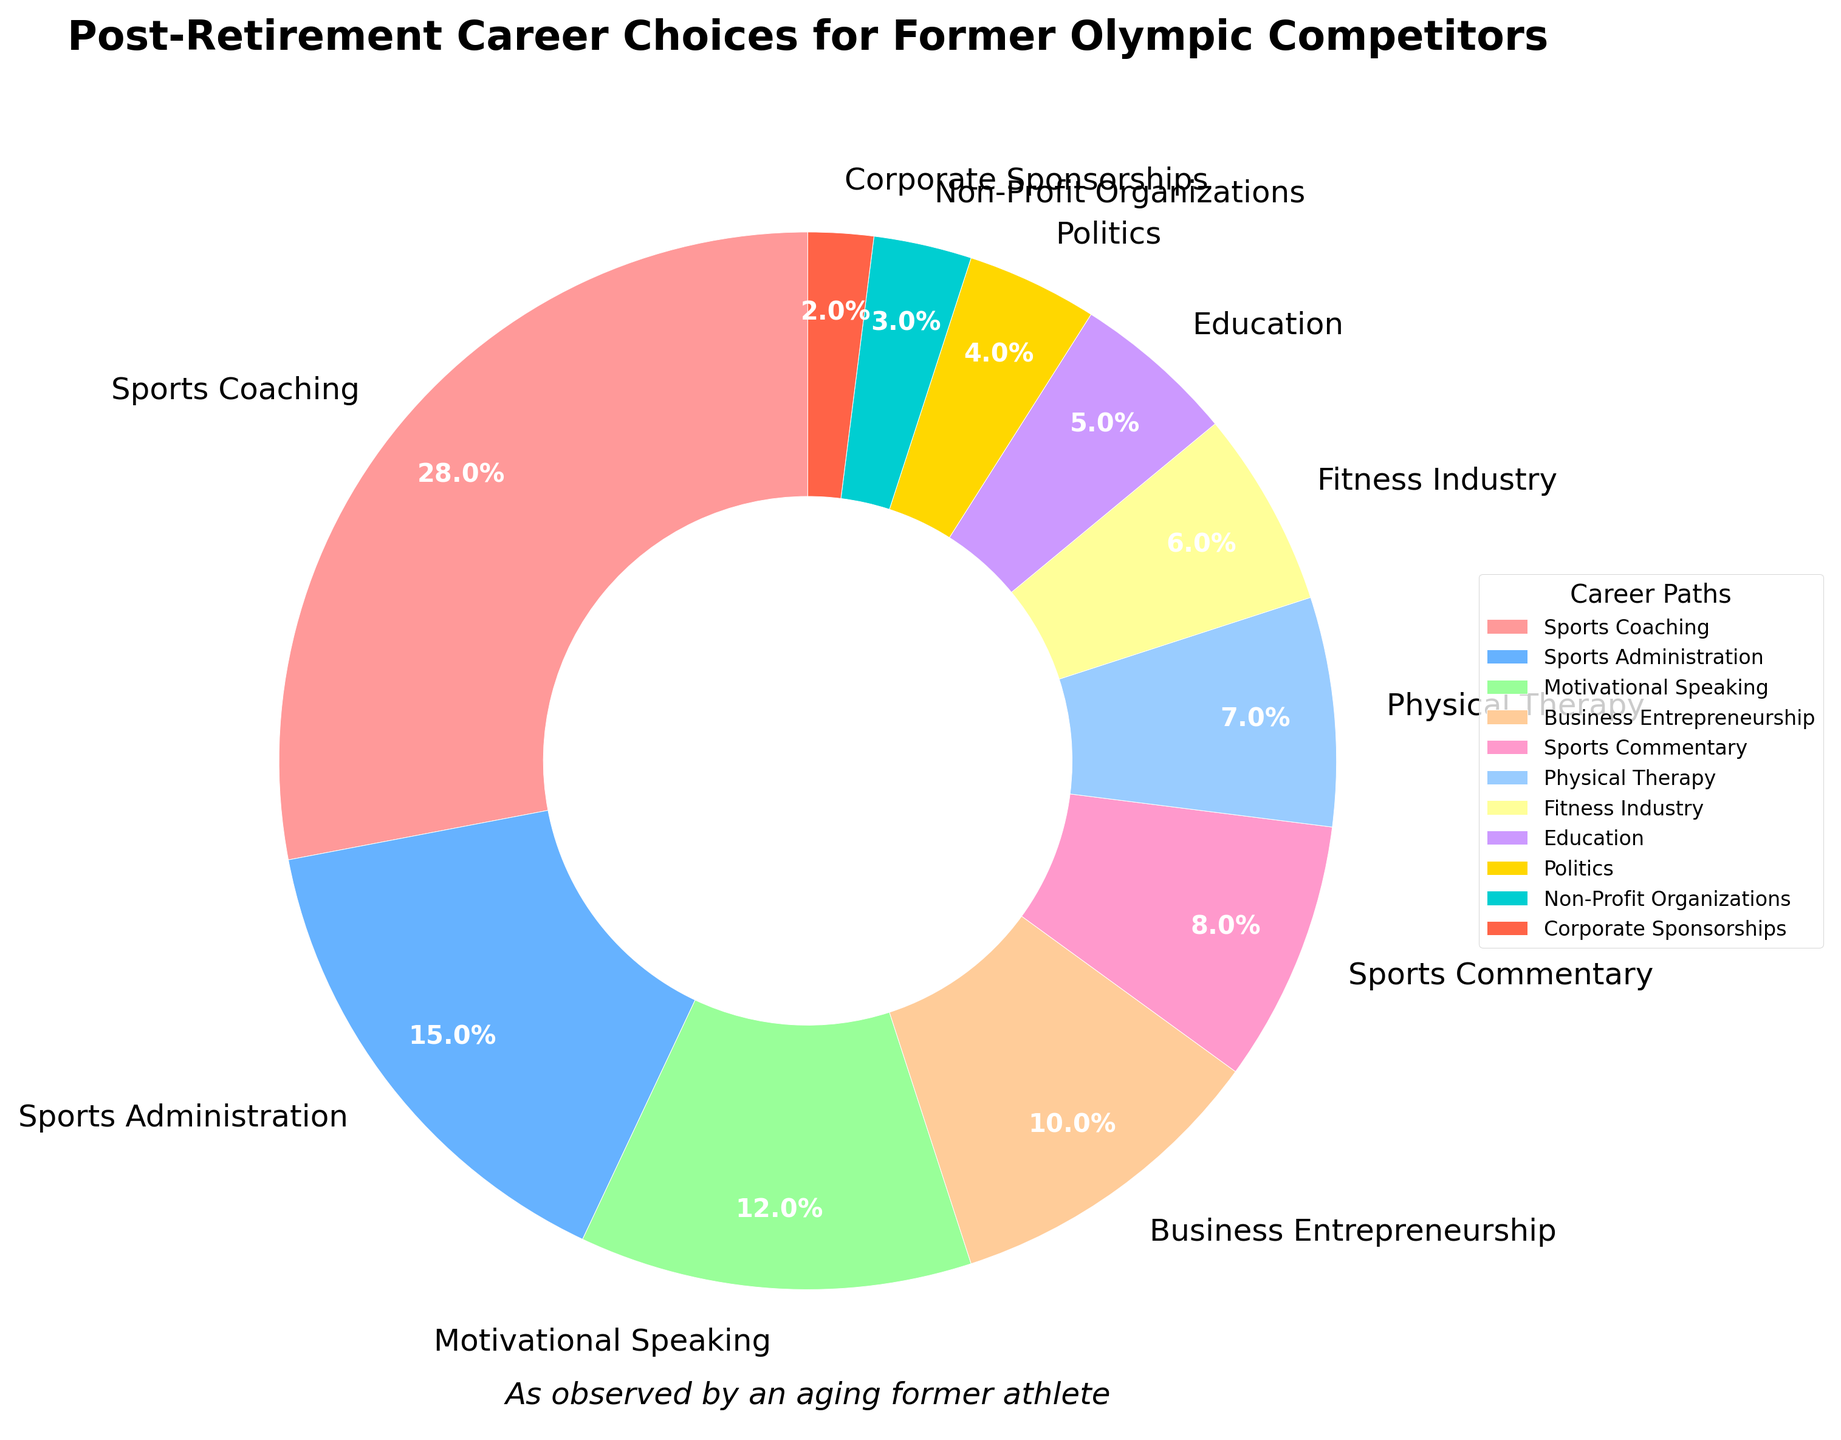Which career path is the most popular among former Olympic competitors? The largest segment in the pie chart represents the most popular career path. In this case, it is Sports Coaching with 28%.
Answer: Sports Coaching What is the combined percentage of former Olympians who went into Business Entrepreneurship and Politics? Add the percentages of the two career paths: Business Entrepreneurship (10%) and Politics (4%). So, 10% + 4% = 14%.
Answer: 14% Which two career paths are equally popular among former Olympic competitors? Look for the segments with the same percentage values. Both Physical Therapy and Fitness Industry have 7% and 6% respectively.
Answer: Physical Therapy and Fitness Industry By how much does the percentage of those in Sports Administration exceed that of those in Education? Subtract the percentage of Education from Sports Administration: 15% - 5% = 10%.
Answer: 10% Is the percentage of former Olympians in Non-Profit Organizations higher or lower than those in Corporate Sponsorships? Compare the two percentages: Non-Profit Organizations is 3% and Corporate Sponsorships is 2%. 3% is higher than 2%.
Answer: Higher What's the difference between the percentage of former Olympians in Motivational Speaking and Sports Commentary? Subtract Sports Commentary from Motivational Speaking: 12% - 8% = 4%.
Answer: 4% Are there more former Olympians in Fitness Industry or in Education? Compare the segment percentages for Fitness Industry (6%) and Education (5%). 6% is greater than 5%.
Answer: Fitness Industry What is the total percentage of former Olympians who continue to work in the sports field (i.e., Sports Coaching, Sports Administration, Sports Commentary, Physical Therapy, Fitness Industry)? Sum the percentages of these career paths: 28% (Sports Coaching) + 15% (Sports Administration) + 8% (Sports Commentary) + 7% (Physical Therapy) + 6% (Fitness Industry) = 64%.
Answer: 64% Which career path has the smallest representation among former Olympians? The smallest segment in the pie chart represents the least popular career path, which is Corporate Sponsorships at 2%.
Answer: Corporate Sponsorships 